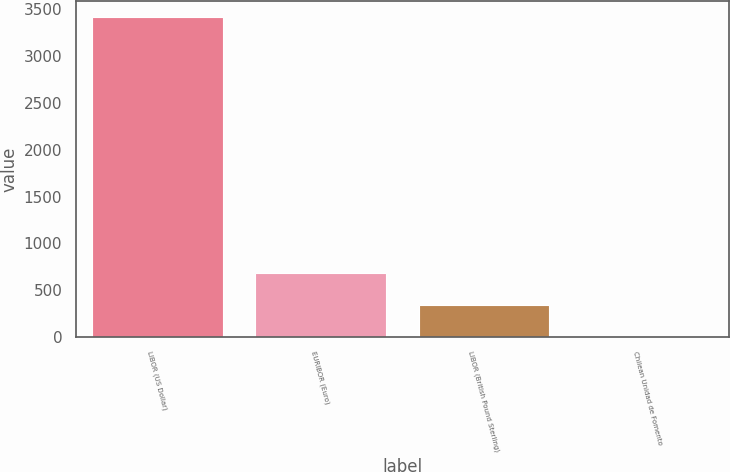Convert chart. <chart><loc_0><loc_0><loc_500><loc_500><bar_chart><fcel>LIBOR (US Dollar)<fcel>EURIBOR (Euro)<fcel>LIBOR (British Pound Sterling)<fcel>Chilean Unidad de Fomento<nl><fcel>3413<fcel>687.4<fcel>346.7<fcel>6<nl></chart> 